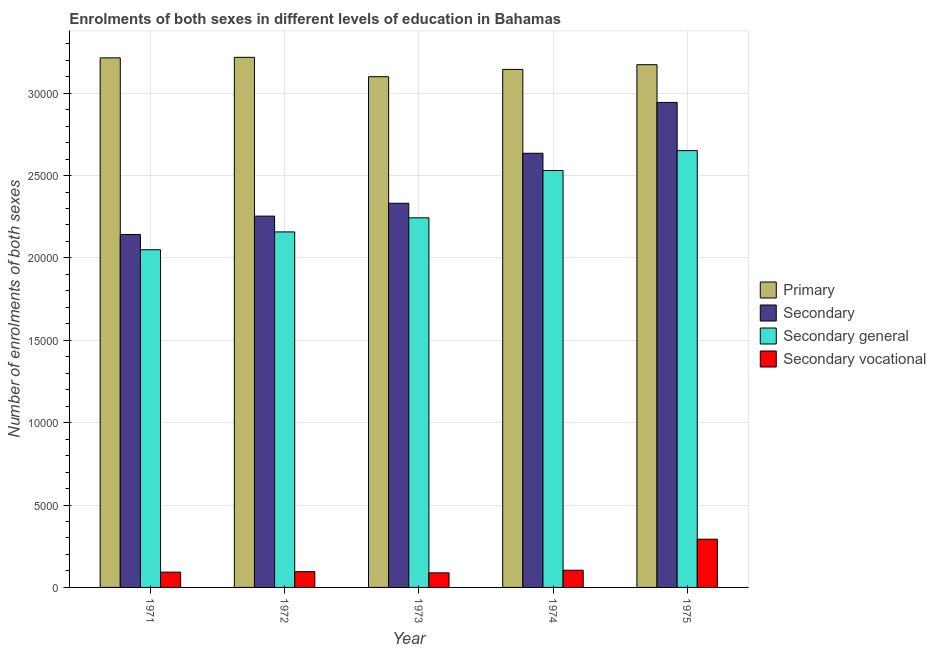How many different coloured bars are there?
Make the answer very short. 4. How many groups of bars are there?
Ensure brevity in your answer.  5. Are the number of bars per tick equal to the number of legend labels?
Provide a short and direct response. Yes. Are the number of bars on each tick of the X-axis equal?
Offer a very short reply. Yes. How many bars are there on the 4th tick from the right?
Your answer should be compact. 4. What is the label of the 3rd group of bars from the left?
Provide a succinct answer. 1973. What is the number of enrolments in primary education in 1974?
Your response must be concise. 3.14e+04. Across all years, what is the maximum number of enrolments in secondary general education?
Offer a terse response. 2.65e+04. Across all years, what is the minimum number of enrolments in primary education?
Offer a terse response. 3.10e+04. In which year was the number of enrolments in secondary vocational education maximum?
Your answer should be compact. 1975. In which year was the number of enrolments in secondary vocational education minimum?
Your answer should be compact. 1973. What is the total number of enrolments in secondary vocational education in the graph?
Give a very brief answer. 6739. What is the difference between the number of enrolments in secondary general education in 1974 and that in 1975?
Your answer should be compact. -1205. What is the difference between the number of enrolments in secondary general education in 1974 and the number of enrolments in primary education in 1975?
Provide a short and direct response. -1205. What is the average number of enrolments in secondary vocational education per year?
Make the answer very short. 1347.8. What is the ratio of the number of enrolments in secondary education in 1973 to that in 1974?
Give a very brief answer. 0.88. Is the number of enrolments in primary education in 1972 less than that in 1974?
Give a very brief answer. No. Is the difference between the number of enrolments in primary education in 1973 and 1974 greater than the difference between the number of enrolments in secondary education in 1973 and 1974?
Offer a very short reply. No. What is the difference between the highest and the second highest number of enrolments in secondary vocational education?
Offer a terse response. 1882. What is the difference between the highest and the lowest number of enrolments in secondary education?
Offer a very short reply. 8016. Is the sum of the number of enrolments in primary education in 1971 and 1972 greater than the maximum number of enrolments in secondary general education across all years?
Your response must be concise. Yes. What does the 4th bar from the left in 1972 represents?
Give a very brief answer. Secondary vocational. What does the 3rd bar from the right in 1973 represents?
Make the answer very short. Secondary. Is it the case that in every year, the sum of the number of enrolments in primary education and number of enrolments in secondary education is greater than the number of enrolments in secondary general education?
Provide a succinct answer. Yes. How many bars are there?
Your response must be concise. 20. Are all the bars in the graph horizontal?
Your response must be concise. No. How many years are there in the graph?
Ensure brevity in your answer.  5. Does the graph contain any zero values?
Provide a succinct answer. No. Does the graph contain grids?
Your answer should be very brief. Yes. Where does the legend appear in the graph?
Offer a very short reply. Center right. How many legend labels are there?
Give a very brief answer. 4. How are the legend labels stacked?
Give a very brief answer. Vertical. What is the title of the graph?
Offer a very short reply. Enrolments of both sexes in different levels of education in Bahamas. What is the label or title of the Y-axis?
Your answer should be compact. Number of enrolments of both sexes. What is the Number of enrolments of both sexes in Primary in 1971?
Give a very brief answer. 3.21e+04. What is the Number of enrolments of both sexes of Secondary in 1971?
Provide a short and direct response. 2.14e+04. What is the Number of enrolments of both sexes of Secondary general in 1971?
Make the answer very short. 2.05e+04. What is the Number of enrolments of both sexes of Secondary vocational in 1971?
Provide a short and direct response. 927. What is the Number of enrolments of both sexes of Primary in 1972?
Provide a succinct answer. 3.22e+04. What is the Number of enrolments of both sexes in Secondary in 1972?
Offer a very short reply. 2.25e+04. What is the Number of enrolments of both sexes in Secondary general in 1972?
Your answer should be compact. 2.16e+04. What is the Number of enrolments of both sexes in Secondary vocational in 1972?
Offer a very short reply. 958. What is the Number of enrolments of both sexes in Primary in 1973?
Ensure brevity in your answer.  3.10e+04. What is the Number of enrolments of both sexes in Secondary in 1973?
Your response must be concise. 2.33e+04. What is the Number of enrolments of both sexes of Secondary general in 1973?
Offer a terse response. 2.24e+04. What is the Number of enrolments of both sexes of Secondary vocational in 1973?
Offer a very short reply. 884. What is the Number of enrolments of both sexes of Primary in 1974?
Your answer should be compact. 3.14e+04. What is the Number of enrolments of both sexes of Secondary in 1974?
Your answer should be compact. 2.64e+04. What is the Number of enrolments of both sexes in Secondary general in 1974?
Your response must be concise. 2.53e+04. What is the Number of enrolments of both sexes of Secondary vocational in 1974?
Offer a very short reply. 1044. What is the Number of enrolments of both sexes in Primary in 1975?
Keep it short and to the point. 3.17e+04. What is the Number of enrolments of both sexes of Secondary in 1975?
Give a very brief answer. 2.94e+04. What is the Number of enrolments of both sexes of Secondary general in 1975?
Provide a succinct answer. 2.65e+04. What is the Number of enrolments of both sexes of Secondary vocational in 1975?
Provide a short and direct response. 2926. Across all years, what is the maximum Number of enrolments of both sexes of Primary?
Make the answer very short. 3.22e+04. Across all years, what is the maximum Number of enrolments of both sexes of Secondary?
Offer a very short reply. 2.94e+04. Across all years, what is the maximum Number of enrolments of both sexes in Secondary general?
Offer a terse response. 2.65e+04. Across all years, what is the maximum Number of enrolments of both sexes in Secondary vocational?
Offer a terse response. 2926. Across all years, what is the minimum Number of enrolments of both sexes of Primary?
Provide a succinct answer. 3.10e+04. Across all years, what is the minimum Number of enrolments of both sexes of Secondary?
Your response must be concise. 2.14e+04. Across all years, what is the minimum Number of enrolments of both sexes in Secondary general?
Keep it short and to the point. 2.05e+04. Across all years, what is the minimum Number of enrolments of both sexes of Secondary vocational?
Your response must be concise. 884. What is the total Number of enrolments of both sexes of Primary in the graph?
Your response must be concise. 1.58e+05. What is the total Number of enrolments of both sexes in Secondary in the graph?
Give a very brief answer. 1.23e+05. What is the total Number of enrolments of both sexes in Secondary general in the graph?
Give a very brief answer. 1.16e+05. What is the total Number of enrolments of both sexes in Secondary vocational in the graph?
Offer a terse response. 6739. What is the difference between the Number of enrolments of both sexes in Primary in 1971 and that in 1972?
Your answer should be compact. -32. What is the difference between the Number of enrolments of both sexes in Secondary in 1971 and that in 1972?
Keep it short and to the point. -1114. What is the difference between the Number of enrolments of both sexes of Secondary general in 1971 and that in 1972?
Offer a terse response. -1083. What is the difference between the Number of enrolments of both sexes in Secondary vocational in 1971 and that in 1972?
Your answer should be very brief. -31. What is the difference between the Number of enrolments of both sexes in Primary in 1971 and that in 1973?
Provide a succinct answer. 1144. What is the difference between the Number of enrolments of both sexes of Secondary in 1971 and that in 1973?
Offer a very short reply. -1895. What is the difference between the Number of enrolments of both sexes of Secondary general in 1971 and that in 1973?
Provide a succinct answer. -1938. What is the difference between the Number of enrolments of both sexes in Primary in 1971 and that in 1974?
Your response must be concise. 701. What is the difference between the Number of enrolments of both sexes in Secondary in 1971 and that in 1974?
Give a very brief answer. -4929. What is the difference between the Number of enrolments of both sexes in Secondary general in 1971 and that in 1974?
Your answer should be compact. -4812. What is the difference between the Number of enrolments of both sexes in Secondary vocational in 1971 and that in 1974?
Your answer should be compact. -117. What is the difference between the Number of enrolments of both sexes in Primary in 1971 and that in 1975?
Offer a terse response. 415. What is the difference between the Number of enrolments of both sexes of Secondary in 1971 and that in 1975?
Ensure brevity in your answer.  -8016. What is the difference between the Number of enrolments of both sexes of Secondary general in 1971 and that in 1975?
Ensure brevity in your answer.  -6017. What is the difference between the Number of enrolments of both sexes in Secondary vocational in 1971 and that in 1975?
Make the answer very short. -1999. What is the difference between the Number of enrolments of both sexes in Primary in 1972 and that in 1973?
Offer a very short reply. 1176. What is the difference between the Number of enrolments of both sexes in Secondary in 1972 and that in 1973?
Provide a short and direct response. -781. What is the difference between the Number of enrolments of both sexes in Secondary general in 1972 and that in 1973?
Your answer should be very brief. -855. What is the difference between the Number of enrolments of both sexes of Primary in 1972 and that in 1974?
Provide a succinct answer. 733. What is the difference between the Number of enrolments of both sexes of Secondary in 1972 and that in 1974?
Make the answer very short. -3815. What is the difference between the Number of enrolments of both sexes in Secondary general in 1972 and that in 1974?
Make the answer very short. -3729. What is the difference between the Number of enrolments of both sexes in Secondary vocational in 1972 and that in 1974?
Give a very brief answer. -86. What is the difference between the Number of enrolments of both sexes in Primary in 1972 and that in 1975?
Provide a short and direct response. 447. What is the difference between the Number of enrolments of both sexes of Secondary in 1972 and that in 1975?
Make the answer very short. -6902. What is the difference between the Number of enrolments of both sexes in Secondary general in 1972 and that in 1975?
Your answer should be compact. -4934. What is the difference between the Number of enrolments of both sexes of Secondary vocational in 1972 and that in 1975?
Make the answer very short. -1968. What is the difference between the Number of enrolments of both sexes of Primary in 1973 and that in 1974?
Provide a short and direct response. -443. What is the difference between the Number of enrolments of both sexes in Secondary in 1973 and that in 1974?
Ensure brevity in your answer.  -3034. What is the difference between the Number of enrolments of both sexes in Secondary general in 1973 and that in 1974?
Offer a terse response. -2874. What is the difference between the Number of enrolments of both sexes in Secondary vocational in 1973 and that in 1974?
Your answer should be very brief. -160. What is the difference between the Number of enrolments of both sexes in Primary in 1973 and that in 1975?
Your answer should be very brief. -729. What is the difference between the Number of enrolments of both sexes in Secondary in 1973 and that in 1975?
Your response must be concise. -6121. What is the difference between the Number of enrolments of both sexes of Secondary general in 1973 and that in 1975?
Provide a succinct answer. -4079. What is the difference between the Number of enrolments of both sexes in Secondary vocational in 1973 and that in 1975?
Provide a short and direct response. -2042. What is the difference between the Number of enrolments of both sexes of Primary in 1974 and that in 1975?
Offer a very short reply. -286. What is the difference between the Number of enrolments of both sexes in Secondary in 1974 and that in 1975?
Your answer should be compact. -3087. What is the difference between the Number of enrolments of both sexes of Secondary general in 1974 and that in 1975?
Offer a terse response. -1205. What is the difference between the Number of enrolments of both sexes of Secondary vocational in 1974 and that in 1975?
Offer a very short reply. -1882. What is the difference between the Number of enrolments of both sexes of Primary in 1971 and the Number of enrolments of both sexes of Secondary in 1972?
Your answer should be very brief. 9606. What is the difference between the Number of enrolments of both sexes of Primary in 1971 and the Number of enrolments of both sexes of Secondary general in 1972?
Make the answer very short. 1.06e+04. What is the difference between the Number of enrolments of both sexes of Primary in 1971 and the Number of enrolments of both sexes of Secondary vocational in 1972?
Provide a short and direct response. 3.12e+04. What is the difference between the Number of enrolments of both sexes in Secondary in 1971 and the Number of enrolments of both sexes in Secondary general in 1972?
Your response must be concise. -156. What is the difference between the Number of enrolments of both sexes in Secondary in 1971 and the Number of enrolments of both sexes in Secondary vocational in 1972?
Your answer should be compact. 2.05e+04. What is the difference between the Number of enrolments of both sexes of Secondary general in 1971 and the Number of enrolments of both sexes of Secondary vocational in 1972?
Your response must be concise. 1.95e+04. What is the difference between the Number of enrolments of both sexes of Primary in 1971 and the Number of enrolments of both sexes of Secondary in 1973?
Your answer should be very brief. 8825. What is the difference between the Number of enrolments of both sexes of Primary in 1971 and the Number of enrolments of both sexes of Secondary general in 1973?
Your answer should be compact. 9709. What is the difference between the Number of enrolments of both sexes of Primary in 1971 and the Number of enrolments of both sexes of Secondary vocational in 1973?
Offer a terse response. 3.13e+04. What is the difference between the Number of enrolments of both sexes in Secondary in 1971 and the Number of enrolments of both sexes in Secondary general in 1973?
Ensure brevity in your answer.  -1011. What is the difference between the Number of enrolments of both sexes of Secondary in 1971 and the Number of enrolments of both sexes of Secondary vocational in 1973?
Your response must be concise. 2.05e+04. What is the difference between the Number of enrolments of both sexes of Secondary general in 1971 and the Number of enrolments of both sexes of Secondary vocational in 1973?
Give a very brief answer. 1.96e+04. What is the difference between the Number of enrolments of both sexes in Primary in 1971 and the Number of enrolments of both sexes in Secondary in 1974?
Your answer should be very brief. 5791. What is the difference between the Number of enrolments of both sexes of Primary in 1971 and the Number of enrolments of both sexes of Secondary general in 1974?
Offer a very short reply. 6835. What is the difference between the Number of enrolments of both sexes in Primary in 1971 and the Number of enrolments of both sexes in Secondary vocational in 1974?
Offer a very short reply. 3.11e+04. What is the difference between the Number of enrolments of both sexes in Secondary in 1971 and the Number of enrolments of both sexes in Secondary general in 1974?
Your answer should be compact. -3885. What is the difference between the Number of enrolments of both sexes in Secondary in 1971 and the Number of enrolments of both sexes in Secondary vocational in 1974?
Provide a succinct answer. 2.04e+04. What is the difference between the Number of enrolments of both sexes in Secondary general in 1971 and the Number of enrolments of both sexes in Secondary vocational in 1974?
Offer a terse response. 1.95e+04. What is the difference between the Number of enrolments of both sexes in Primary in 1971 and the Number of enrolments of both sexes in Secondary in 1975?
Your response must be concise. 2704. What is the difference between the Number of enrolments of both sexes in Primary in 1971 and the Number of enrolments of both sexes in Secondary general in 1975?
Make the answer very short. 5630. What is the difference between the Number of enrolments of both sexes in Primary in 1971 and the Number of enrolments of both sexes in Secondary vocational in 1975?
Ensure brevity in your answer.  2.92e+04. What is the difference between the Number of enrolments of both sexes of Secondary in 1971 and the Number of enrolments of both sexes of Secondary general in 1975?
Give a very brief answer. -5090. What is the difference between the Number of enrolments of both sexes of Secondary in 1971 and the Number of enrolments of both sexes of Secondary vocational in 1975?
Offer a very short reply. 1.85e+04. What is the difference between the Number of enrolments of both sexes of Secondary general in 1971 and the Number of enrolments of both sexes of Secondary vocational in 1975?
Make the answer very short. 1.76e+04. What is the difference between the Number of enrolments of both sexes of Primary in 1972 and the Number of enrolments of both sexes of Secondary in 1973?
Provide a succinct answer. 8857. What is the difference between the Number of enrolments of both sexes of Primary in 1972 and the Number of enrolments of both sexes of Secondary general in 1973?
Provide a short and direct response. 9741. What is the difference between the Number of enrolments of both sexes in Primary in 1972 and the Number of enrolments of both sexes in Secondary vocational in 1973?
Give a very brief answer. 3.13e+04. What is the difference between the Number of enrolments of both sexes of Secondary in 1972 and the Number of enrolments of both sexes of Secondary general in 1973?
Your answer should be compact. 103. What is the difference between the Number of enrolments of both sexes of Secondary in 1972 and the Number of enrolments of both sexes of Secondary vocational in 1973?
Provide a succinct answer. 2.17e+04. What is the difference between the Number of enrolments of both sexes of Secondary general in 1972 and the Number of enrolments of both sexes of Secondary vocational in 1973?
Your answer should be very brief. 2.07e+04. What is the difference between the Number of enrolments of both sexes in Primary in 1972 and the Number of enrolments of both sexes in Secondary in 1974?
Offer a terse response. 5823. What is the difference between the Number of enrolments of both sexes in Primary in 1972 and the Number of enrolments of both sexes in Secondary general in 1974?
Keep it short and to the point. 6867. What is the difference between the Number of enrolments of both sexes of Primary in 1972 and the Number of enrolments of both sexes of Secondary vocational in 1974?
Ensure brevity in your answer.  3.11e+04. What is the difference between the Number of enrolments of both sexes in Secondary in 1972 and the Number of enrolments of both sexes in Secondary general in 1974?
Your answer should be compact. -2771. What is the difference between the Number of enrolments of both sexes in Secondary in 1972 and the Number of enrolments of both sexes in Secondary vocational in 1974?
Keep it short and to the point. 2.15e+04. What is the difference between the Number of enrolments of both sexes of Secondary general in 1972 and the Number of enrolments of both sexes of Secondary vocational in 1974?
Give a very brief answer. 2.05e+04. What is the difference between the Number of enrolments of both sexes of Primary in 1972 and the Number of enrolments of both sexes of Secondary in 1975?
Your answer should be very brief. 2736. What is the difference between the Number of enrolments of both sexes in Primary in 1972 and the Number of enrolments of both sexes in Secondary general in 1975?
Ensure brevity in your answer.  5662. What is the difference between the Number of enrolments of both sexes of Primary in 1972 and the Number of enrolments of both sexes of Secondary vocational in 1975?
Offer a very short reply. 2.92e+04. What is the difference between the Number of enrolments of both sexes in Secondary in 1972 and the Number of enrolments of both sexes in Secondary general in 1975?
Keep it short and to the point. -3976. What is the difference between the Number of enrolments of both sexes of Secondary in 1972 and the Number of enrolments of both sexes of Secondary vocational in 1975?
Your response must be concise. 1.96e+04. What is the difference between the Number of enrolments of both sexes in Secondary general in 1972 and the Number of enrolments of both sexes in Secondary vocational in 1975?
Make the answer very short. 1.87e+04. What is the difference between the Number of enrolments of both sexes in Primary in 1973 and the Number of enrolments of both sexes in Secondary in 1974?
Your response must be concise. 4647. What is the difference between the Number of enrolments of both sexes of Primary in 1973 and the Number of enrolments of both sexes of Secondary general in 1974?
Ensure brevity in your answer.  5691. What is the difference between the Number of enrolments of both sexes of Primary in 1973 and the Number of enrolments of both sexes of Secondary vocational in 1974?
Make the answer very short. 3.00e+04. What is the difference between the Number of enrolments of both sexes of Secondary in 1973 and the Number of enrolments of both sexes of Secondary general in 1974?
Provide a short and direct response. -1990. What is the difference between the Number of enrolments of both sexes of Secondary in 1973 and the Number of enrolments of both sexes of Secondary vocational in 1974?
Ensure brevity in your answer.  2.23e+04. What is the difference between the Number of enrolments of both sexes of Secondary general in 1973 and the Number of enrolments of both sexes of Secondary vocational in 1974?
Give a very brief answer. 2.14e+04. What is the difference between the Number of enrolments of both sexes in Primary in 1973 and the Number of enrolments of both sexes in Secondary in 1975?
Offer a terse response. 1560. What is the difference between the Number of enrolments of both sexes of Primary in 1973 and the Number of enrolments of both sexes of Secondary general in 1975?
Your response must be concise. 4486. What is the difference between the Number of enrolments of both sexes in Primary in 1973 and the Number of enrolments of both sexes in Secondary vocational in 1975?
Offer a very short reply. 2.81e+04. What is the difference between the Number of enrolments of both sexes of Secondary in 1973 and the Number of enrolments of both sexes of Secondary general in 1975?
Provide a succinct answer. -3195. What is the difference between the Number of enrolments of both sexes of Secondary in 1973 and the Number of enrolments of both sexes of Secondary vocational in 1975?
Offer a very short reply. 2.04e+04. What is the difference between the Number of enrolments of both sexes in Secondary general in 1973 and the Number of enrolments of both sexes in Secondary vocational in 1975?
Ensure brevity in your answer.  1.95e+04. What is the difference between the Number of enrolments of both sexes in Primary in 1974 and the Number of enrolments of both sexes in Secondary in 1975?
Ensure brevity in your answer.  2003. What is the difference between the Number of enrolments of both sexes in Primary in 1974 and the Number of enrolments of both sexes in Secondary general in 1975?
Ensure brevity in your answer.  4929. What is the difference between the Number of enrolments of both sexes in Primary in 1974 and the Number of enrolments of both sexes in Secondary vocational in 1975?
Provide a short and direct response. 2.85e+04. What is the difference between the Number of enrolments of both sexes in Secondary in 1974 and the Number of enrolments of both sexes in Secondary general in 1975?
Provide a short and direct response. -161. What is the difference between the Number of enrolments of both sexes in Secondary in 1974 and the Number of enrolments of both sexes in Secondary vocational in 1975?
Make the answer very short. 2.34e+04. What is the difference between the Number of enrolments of both sexes of Secondary general in 1974 and the Number of enrolments of both sexes of Secondary vocational in 1975?
Keep it short and to the point. 2.24e+04. What is the average Number of enrolments of both sexes of Primary per year?
Ensure brevity in your answer.  3.17e+04. What is the average Number of enrolments of both sexes of Secondary per year?
Your response must be concise. 2.46e+04. What is the average Number of enrolments of both sexes of Secondary general per year?
Offer a very short reply. 2.33e+04. What is the average Number of enrolments of both sexes in Secondary vocational per year?
Your answer should be compact. 1347.8. In the year 1971, what is the difference between the Number of enrolments of both sexes in Primary and Number of enrolments of both sexes in Secondary?
Offer a terse response. 1.07e+04. In the year 1971, what is the difference between the Number of enrolments of both sexes of Primary and Number of enrolments of both sexes of Secondary general?
Ensure brevity in your answer.  1.16e+04. In the year 1971, what is the difference between the Number of enrolments of both sexes of Primary and Number of enrolments of both sexes of Secondary vocational?
Provide a succinct answer. 3.12e+04. In the year 1971, what is the difference between the Number of enrolments of both sexes in Secondary and Number of enrolments of both sexes in Secondary general?
Your answer should be compact. 927. In the year 1971, what is the difference between the Number of enrolments of both sexes in Secondary and Number of enrolments of both sexes in Secondary vocational?
Provide a succinct answer. 2.05e+04. In the year 1971, what is the difference between the Number of enrolments of both sexes in Secondary general and Number of enrolments of both sexes in Secondary vocational?
Your response must be concise. 1.96e+04. In the year 1972, what is the difference between the Number of enrolments of both sexes of Primary and Number of enrolments of both sexes of Secondary?
Your answer should be very brief. 9638. In the year 1972, what is the difference between the Number of enrolments of both sexes in Primary and Number of enrolments of both sexes in Secondary general?
Your answer should be compact. 1.06e+04. In the year 1972, what is the difference between the Number of enrolments of both sexes of Primary and Number of enrolments of both sexes of Secondary vocational?
Provide a short and direct response. 3.12e+04. In the year 1972, what is the difference between the Number of enrolments of both sexes of Secondary and Number of enrolments of both sexes of Secondary general?
Keep it short and to the point. 958. In the year 1972, what is the difference between the Number of enrolments of both sexes in Secondary and Number of enrolments of both sexes in Secondary vocational?
Your answer should be compact. 2.16e+04. In the year 1972, what is the difference between the Number of enrolments of both sexes of Secondary general and Number of enrolments of both sexes of Secondary vocational?
Make the answer very short. 2.06e+04. In the year 1973, what is the difference between the Number of enrolments of both sexes of Primary and Number of enrolments of both sexes of Secondary?
Provide a short and direct response. 7681. In the year 1973, what is the difference between the Number of enrolments of both sexes of Primary and Number of enrolments of both sexes of Secondary general?
Keep it short and to the point. 8565. In the year 1973, what is the difference between the Number of enrolments of both sexes of Primary and Number of enrolments of both sexes of Secondary vocational?
Your answer should be compact. 3.01e+04. In the year 1973, what is the difference between the Number of enrolments of both sexes of Secondary and Number of enrolments of both sexes of Secondary general?
Provide a short and direct response. 884. In the year 1973, what is the difference between the Number of enrolments of both sexes of Secondary and Number of enrolments of both sexes of Secondary vocational?
Make the answer very short. 2.24e+04. In the year 1973, what is the difference between the Number of enrolments of both sexes in Secondary general and Number of enrolments of both sexes in Secondary vocational?
Your response must be concise. 2.15e+04. In the year 1974, what is the difference between the Number of enrolments of both sexes of Primary and Number of enrolments of both sexes of Secondary?
Give a very brief answer. 5090. In the year 1974, what is the difference between the Number of enrolments of both sexes in Primary and Number of enrolments of both sexes in Secondary general?
Provide a succinct answer. 6134. In the year 1974, what is the difference between the Number of enrolments of both sexes in Primary and Number of enrolments of both sexes in Secondary vocational?
Give a very brief answer. 3.04e+04. In the year 1974, what is the difference between the Number of enrolments of both sexes in Secondary and Number of enrolments of both sexes in Secondary general?
Your response must be concise. 1044. In the year 1974, what is the difference between the Number of enrolments of both sexes of Secondary and Number of enrolments of both sexes of Secondary vocational?
Provide a succinct answer. 2.53e+04. In the year 1974, what is the difference between the Number of enrolments of both sexes in Secondary general and Number of enrolments of both sexes in Secondary vocational?
Provide a succinct answer. 2.43e+04. In the year 1975, what is the difference between the Number of enrolments of both sexes of Primary and Number of enrolments of both sexes of Secondary?
Provide a short and direct response. 2289. In the year 1975, what is the difference between the Number of enrolments of both sexes of Primary and Number of enrolments of both sexes of Secondary general?
Offer a terse response. 5215. In the year 1975, what is the difference between the Number of enrolments of both sexes in Primary and Number of enrolments of both sexes in Secondary vocational?
Your answer should be very brief. 2.88e+04. In the year 1975, what is the difference between the Number of enrolments of both sexes in Secondary and Number of enrolments of both sexes in Secondary general?
Provide a short and direct response. 2926. In the year 1975, what is the difference between the Number of enrolments of both sexes of Secondary and Number of enrolments of both sexes of Secondary vocational?
Your answer should be compact. 2.65e+04. In the year 1975, what is the difference between the Number of enrolments of both sexes of Secondary general and Number of enrolments of both sexes of Secondary vocational?
Provide a short and direct response. 2.36e+04. What is the ratio of the Number of enrolments of both sexes in Primary in 1971 to that in 1972?
Provide a short and direct response. 1. What is the ratio of the Number of enrolments of both sexes in Secondary in 1971 to that in 1972?
Provide a succinct answer. 0.95. What is the ratio of the Number of enrolments of both sexes in Secondary general in 1971 to that in 1972?
Offer a very short reply. 0.95. What is the ratio of the Number of enrolments of both sexes in Secondary vocational in 1971 to that in 1972?
Provide a short and direct response. 0.97. What is the ratio of the Number of enrolments of both sexes in Primary in 1971 to that in 1973?
Offer a very short reply. 1.04. What is the ratio of the Number of enrolments of both sexes in Secondary in 1971 to that in 1973?
Offer a very short reply. 0.92. What is the ratio of the Number of enrolments of both sexes in Secondary general in 1971 to that in 1973?
Your response must be concise. 0.91. What is the ratio of the Number of enrolments of both sexes in Secondary vocational in 1971 to that in 1973?
Provide a succinct answer. 1.05. What is the ratio of the Number of enrolments of both sexes of Primary in 1971 to that in 1974?
Keep it short and to the point. 1.02. What is the ratio of the Number of enrolments of both sexes of Secondary in 1971 to that in 1974?
Keep it short and to the point. 0.81. What is the ratio of the Number of enrolments of both sexes in Secondary general in 1971 to that in 1974?
Offer a very short reply. 0.81. What is the ratio of the Number of enrolments of both sexes in Secondary vocational in 1971 to that in 1974?
Provide a short and direct response. 0.89. What is the ratio of the Number of enrolments of both sexes of Primary in 1971 to that in 1975?
Provide a short and direct response. 1.01. What is the ratio of the Number of enrolments of both sexes in Secondary in 1971 to that in 1975?
Provide a succinct answer. 0.73. What is the ratio of the Number of enrolments of both sexes in Secondary general in 1971 to that in 1975?
Ensure brevity in your answer.  0.77. What is the ratio of the Number of enrolments of both sexes of Secondary vocational in 1971 to that in 1975?
Give a very brief answer. 0.32. What is the ratio of the Number of enrolments of both sexes of Primary in 1972 to that in 1973?
Ensure brevity in your answer.  1.04. What is the ratio of the Number of enrolments of both sexes in Secondary in 1972 to that in 1973?
Provide a succinct answer. 0.97. What is the ratio of the Number of enrolments of both sexes of Secondary general in 1972 to that in 1973?
Offer a terse response. 0.96. What is the ratio of the Number of enrolments of both sexes of Secondary vocational in 1972 to that in 1973?
Provide a short and direct response. 1.08. What is the ratio of the Number of enrolments of both sexes of Primary in 1972 to that in 1974?
Ensure brevity in your answer.  1.02. What is the ratio of the Number of enrolments of both sexes in Secondary in 1972 to that in 1974?
Your response must be concise. 0.86. What is the ratio of the Number of enrolments of both sexes in Secondary general in 1972 to that in 1974?
Your response must be concise. 0.85. What is the ratio of the Number of enrolments of both sexes of Secondary vocational in 1972 to that in 1974?
Keep it short and to the point. 0.92. What is the ratio of the Number of enrolments of both sexes in Primary in 1972 to that in 1975?
Offer a very short reply. 1.01. What is the ratio of the Number of enrolments of both sexes of Secondary in 1972 to that in 1975?
Ensure brevity in your answer.  0.77. What is the ratio of the Number of enrolments of both sexes in Secondary general in 1972 to that in 1975?
Make the answer very short. 0.81. What is the ratio of the Number of enrolments of both sexes of Secondary vocational in 1972 to that in 1975?
Your answer should be compact. 0.33. What is the ratio of the Number of enrolments of both sexes in Primary in 1973 to that in 1974?
Provide a short and direct response. 0.99. What is the ratio of the Number of enrolments of both sexes of Secondary in 1973 to that in 1974?
Provide a succinct answer. 0.88. What is the ratio of the Number of enrolments of both sexes of Secondary general in 1973 to that in 1974?
Your answer should be very brief. 0.89. What is the ratio of the Number of enrolments of both sexes in Secondary vocational in 1973 to that in 1974?
Make the answer very short. 0.85. What is the ratio of the Number of enrolments of both sexes in Primary in 1973 to that in 1975?
Offer a very short reply. 0.98. What is the ratio of the Number of enrolments of both sexes in Secondary in 1973 to that in 1975?
Make the answer very short. 0.79. What is the ratio of the Number of enrolments of both sexes of Secondary general in 1973 to that in 1975?
Make the answer very short. 0.85. What is the ratio of the Number of enrolments of both sexes of Secondary vocational in 1973 to that in 1975?
Make the answer very short. 0.3. What is the ratio of the Number of enrolments of both sexes of Primary in 1974 to that in 1975?
Keep it short and to the point. 0.99. What is the ratio of the Number of enrolments of both sexes of Secondary in 1974 to that in 1975?
Your response must be concise. 0.9. What is the ratio of the Number of enrolments of both sexes of Secondary general in 1974 to that in 1975?
Keep it short and to the point. 0.95. What is the ratio of the Number of enrolments of both sexes of Secondary vocational in 1974 to that in 1975?
Offer a terse response. 0.36. What is the difference between the highest and the second highest Number of enrolments of both sexes of Secondary?
Offer a terse response. 3087. What is the difference between the highest and the second highest Number of enrolments of both sexes of Secondary general?
Provide a succinct answer. 1205. What is the difference between the highest and the second highest Number of enrolments of both sexes in Secondary vocational?
Offer a very short reply. 1882. What is the difference between the highest and the lowest Number of enrolments of both sexes in Primary?
Provide a short and direct response. 1176. What is the difference between the highest and the lowest Number of enrolments of both sexes in Secondary?
Make the answer very short. 8016. What is the difference between the highest and the lowest Number of enrolments of both sexes in Secondary general?
Offer a terse response. 6017. What is the difference between the highest and the lowest Number of enrolments of both sexes in Secondary vocational?
Ensure brevity in your answer.  2042. 